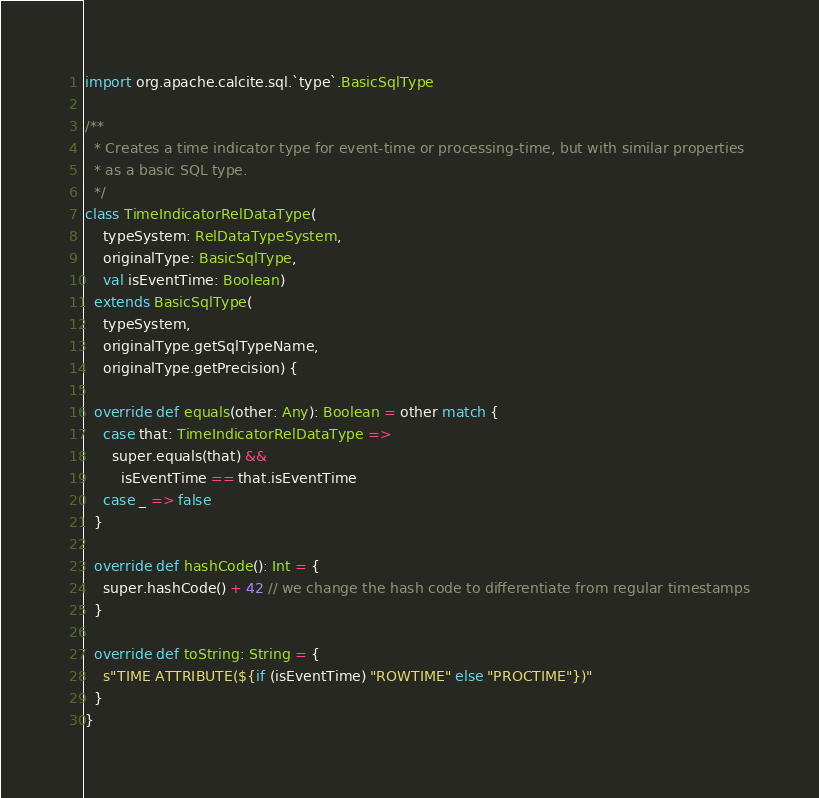Convert code to text. <code><loc_0><loc_0><loc_500><loc_500><_Scala_>import org.apache.calcite.sql.`type`.BasicSqlType

/**
  * Creates a time indicator type for event-time or processing-time, but with similar properties
  * as a basic SQL type.
  */
class TimeIndicatorRelDataType(
    typeSystem: RelDataTypeSystem,
    originalType: BasicSqlType,
    val isEventTime: Boolean)
  extends BasicSqlType(
    typeSystem,
    originalType.getSqlTypeName,
    originalType.getPrecision) {

  override def equals(other: Any): Boolean = other match {
    case that: TimeIndicatorRelDataType =>
      super.equals(that) &&
        isEventTime == that.isEventTime
    case _ => false
  }

  override def hashCode(): Int = {
    super.hashCode() + 42 // we change the hash code to differentiate from regular timestamps
  }

  override def toString: String = {
    s"TIME ATTRIBUTE(${if (isEventTime) "ROWTIME" else "PROCTIME"})"
  }
}
</code> 